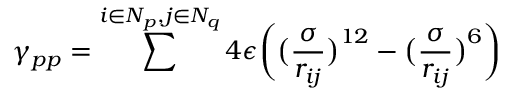<formula> <loc_0><loc_0><loc_500><loc_500>\gamma _ { p p } = \sum ^ { i \in N _ { p } , j \in N _ { q } } 4 \epsilon \left ( \left ( \frac { \sigma } { r _ { i j } } \right ) ^ { 1 2 } - \left ( \frac { \sigma } { r _ { i j } } \right ) ^ { 6 } \right )</formula> 